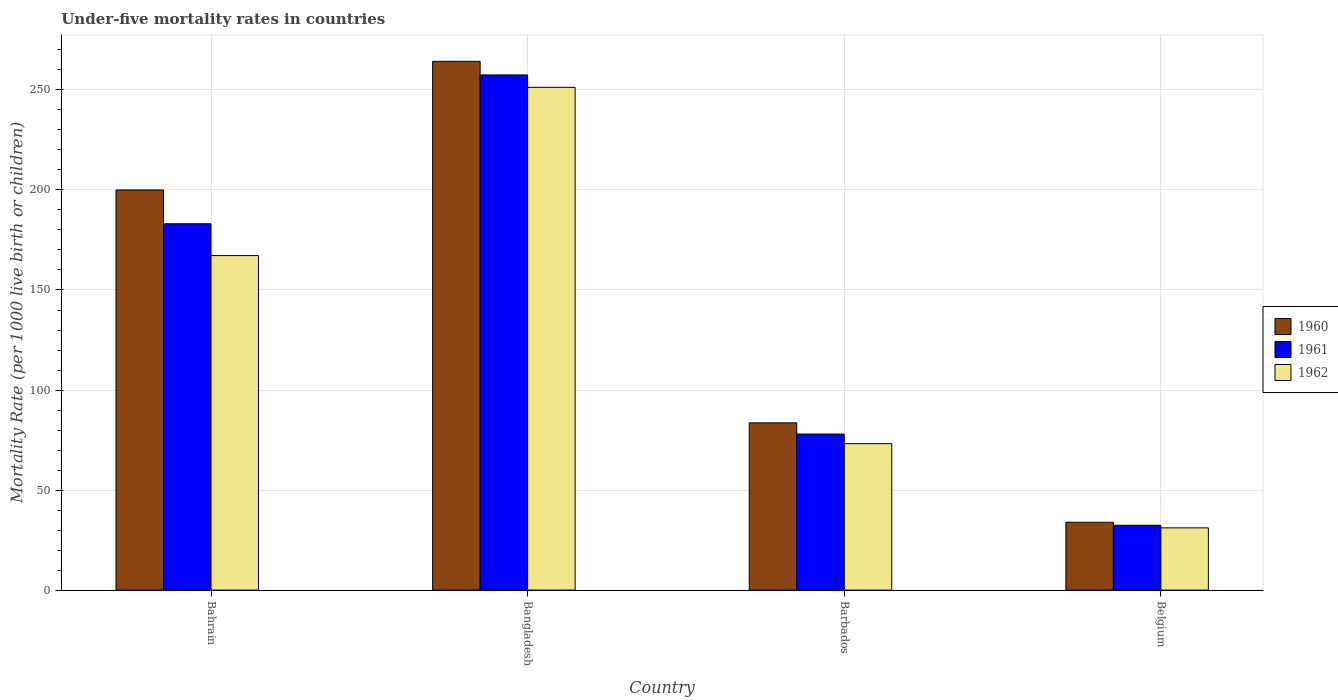How many different coloured bars are there?
Your answer should be compact. 3. Are the number of bars on each tick of the X-axis equal?
Offer a very short reply. Yes. How many bars are there on the 1st tick from the left?
Give a very brief answer. 3. How many bars are there on the 2nd tick from the right?
Provide a short and direct response. 3. What is the under-five mortality rate in 1962 in Belgium?
Provide a short and direct response. 31.1. Across all countries, what is the maximum under-five mortality rate in 1961?
Keep it short and to the point. 257.5. Across all countries, what is the minimum under-five mortality rate in 1960?
Provide a succinct answer. 33.9. What is the total under-five mortality rate in 1961 in the graph?
Provide a short and direct response. 551. What is the difference between the under-five mortality rate in 1960 in Bahrain and that in Bangladesh?
Make the answer very short. -64.3. What is the difference between the under-five mortality rate in 1960 in Bangladesh and the under-five mortality rate in 1962 in Barbados?
Your response must be concise. 191.1. What is the average under-five mortality rate in 1961 per country?
Your response must be concise. 137.75. What is the difference between the under-five mortality rate of/in 1961 and under-five mortality rate of/in 1960 in Bahrain?
Provide a short and direct response. -16.9. What is the ratio of the under-five mortality rate in 1960 in Barbados to that in Belgium?
Your response must be concise. 2.47. What is the difference between the highest and the second highest under-five mortality rate in 1960?
Offer a terse response. 180.7. What is the difference between the highest and the lowest under-five mortality rate in 1960?
Ensure brevity in your answer.  230.4. In how many countries, is the under-five mortality rate in 1960 greater than the average under-five mortality rate in 1960 taken over all countries?
Offer a very short reply. 2. What does the 3rd bar from the right in Belgium represents?
Make the answer very short. 1960. Is it the case that in every country, the sum of the under-five mortality rate in 1960 and under-five mortality rate in 1961 is greater than the under-five mortality rate in 1962?
Provide a short and direct response. Yes. Are all the bars in the graph horizontal?
Provide a succinct answer. No. Does the graph contain grids?
Offer a very short reply. Yes. What is the title of the graph?
Your response must be concise. Under-five mortality rates in countries. What is the label or title of the Y-axis?
Your response must be concise. Mortality Rate (per 1000 live birth or children). What is the Mortality Rate (per 1000 live birth or children) of 1961 in Bahrain?
Offer a terse response. 183.1. What is the Mortality Rate (per 1000 live birth or children) in 1962 in Bahrain?
Make the answer very short. 167.2. What is the Mortality Rate (per 1000 live birth or children) of 1960 in Bangladesh?
Offer a very short reply. 264.3. What is the Mortality Rate (per 1000 live birth or children) of 1961 in Bangladesh?
Your answer should be very brief. 257.5. What is the Mortality Rate (per 1000 live birth or children) of 1962 in Bangladesh?
Your answer should be compact. 251.3. What is the Mortality Rate (per 1000 live birth or children) of 1960 in Barbados?
Provide a succinct answer. 83.6. What is the Mortality Rate (per 1000 live birth or children) in 1962 in Barbados?
Your response must be concise. 73.2. What is the Mortality Rate (per 1000 live birth or children) in 1960 in Belgium?
Offer a very short reply. 33.9. What is the Mortality Rate (per 1000 live birth or children) in 1961 in Belgium?
Ensure brevity in your answer.  32.4. What is the Mortality Rate (per 1000 live birth or children) in 1962 in Belgium?
Offer a very short reply. 31.1. Across all countries, what is the maximum Mortality Rate (per 1000 live birth or children) of 1960?
Offer a terse response. 264.3. Across all countries, what is the maximum Mortality Rate (per 1000 live birth or children) of 1961?
Make the answer very short. 257.5. Across all countries, what is the maximum Mortality Rate (per 1000 live birth or children) of 1962?
Your answer should be compact. 251.3. Across all countries, what is the minimum Mortality Rate (per 1000 live birth or children) in 1960?
Your answer should be compact. 33.9. Across all countries, what is the minimum Mortality Rate (per 1000 live birth or children) of 1961?
Ensure brevity in your answer.  32.4. Across all countries, what is the minimum Mortality Rate (per 1000 live birth or children) of 1962?
Your response must be concise. 31.1. What is the total Mortality Rate (per 1000 live birth or children) in 1960 in the graph?
Keep it short and to the point. 581.8. What is the total Mortality Rate (per 1000 live birth or children) of 1961 in the graph?
Keep it short and to the point. 551. What is the total Mortality Rate (per 1000 live birth or children) of 1962 in the graph?
Your answer should be very brief. 522.8. What is the difference between the Mortality Rate (per 1000 live birth or children) in 1960 in Bahrain and that in Bangladesh?
Offer a very short reply. -64.3. What is the difference between the Mortality Rate (per 1000 live birth or children) in 1961 in Bahrain and that in Bangladesh?
Provide a succinct answer. -74.4. What is the difference between the Mortality Rate (per 1000 live birth or children) of 1962 in Bahrain and that in Bangladesh?
Make the answer very short. -84.1. What is the difference between the Mortality Rate (per 1000 live birth or children) of 1960 in Bahrain and that in Barbados?
Offer a very short reply. 116.4. What is the difference between the Mortality Rate (per 1000 live birth or children) of 1961 in Bahrain and that in Barbados?
Your answer should be compact. 105.1. What is the difference between the Mortality Rate (per 1000 live birth or children) in 1962 in Bahrain and that in Barbados?
Provide a short and direct response. 94. What is the difference between the Mortality Rate (per 1000 live birth or children) in 1960 in Bahrain and that in Belgium?
Give a very brief answer. 166.1. What is the difference between the Mortality Rate (per 1000 live birth or children) in 1961 in Bahrain and that in Belgium?
Offer a terse response. 150.7. What is the difference between the Mortality Rate (per 1000 live birth or children) of 1962 in Bahrain and that in Belgium?
Provide a short and direct response. 136.1. What is the difference between the Mortality Rate (per 1000 live birth or children) of 1960 in Bangladesh and that in Barbados?
Your response must be concise. 180.7. What is the difference between the Mortality Rate (per 1000 live birth or children) in 1961 in Bangladesh and that in Barbados?
Your response must be concise. 179.5. What is the difference between the Mortality Rate (per 1000 live birth or children) of 1962 in Bangladesh and that in Barbados?
Your answer should be compact. 178.1. What is the difference between the Mortality Rate (per 1000 live birth or children) in 1960 in Bangladesh and that in Belgium?
Give a very brief answer. 230.4. What is the difference between the Mortality Rate (per 1000 live birth or children) in 1961 in Bangladesh and that in Belgium?
Your response must be concise. 225.1. What is the difference between the Mortality Rate (per 1000 live birth or children) of 1962 in Bangladesh and that in Belgium?
Ensure brevity in your answer.  220.2. What is the difference between the Mortality Rate (per 1000 live birth or children) of 1960 in Barbados and that in Belgium?
Your response must be concise. 49.7. What is the difference between the Mortality Rate (per 1000 live birth or children) of 1961 in Barbados and that in Belgium?
Your answer should be very brief. 45.6. What is the difference between the Mortality Rate (per 1000 live birth or children) of 1962 in Barbados and that in Belgium?
Your answer should be very brief. 42.1. What is the difference between the Mortality Rate (per 1000 live birth or children) in 1960 in Bahrain and the Mortality Rate (per 1000 live birth or children) in 1961 in Bangladesh?
Keep it short and to the point. -57.5. What is the difference between the Mortality Rate (per 1000 live birth or children) in 1960 in Bahrain and the Mortality Rate (per 1000 live birth or children) in 1962 in Bangladesh?
Provide a succinct answer. -51.3. What is the difference between the Mortality Rate (per 1000 live birth or children) in 1961 in Bahrain and the Mortality Rate (per 1000 live birth or children) in 1962 in Bangladesh?
Keep it short and to the point. -68.2. What is the difference between the Mortality Rate (per 1000 live birth or children) of 1960 in Bahrain and the Mortality Rate (per 1000 live birth or children) of 1961 in Barbados?
Offer a terse response. 122. What is the difference between the Mortality Rate (per 1000 live birth or children) in 1960 in Bahrain and the Mortality Rate (per 1000 live birth or children) in 1962 in Barbados?
Offer a very short reply. 126.8. What is the difference between the Mortality Rate (per 1000 live birth or children) in 1961 in Bahrain and the Mortality Rate (per 1000 live birth or children) in 1962 in Barbados?
Keep it short and to the point. 109.9. What is the difference between the Mortality Rate (per 1000 live birth or children) in 1960 in Bahrain and the Mortality Rate (per 1000 live birth or children) in 1961 in Belgium?
Make the answer very short. 167.6. What is the difference between the Mortality Rate (per 1000 live birth or children) of 1960 in Bahrain and the Mortality Rate (per 1000 live birth or children) of 1962 in Belgium?
Your response must be concise. 168.9. What is the difference between the Mortality Rate (per 1000 live birth or children) in 1961 in Bahrain and the Mortality Rate (per 1000 live birth or children) in 1962 in Belgium?
Ensure brevity in your answer.  152. What is the difference between the Mortality Rate (per 1000 live birth or children) of 1960 in Bangladesh and the Mortality Rate (per 1000 live birth or children) of 1961 in Barbados?
Provide a short and direct response. 186.3. What is the difference between the Mortality Rate (per 1000 live birth or children) in 1960 in Bangladesh and the Mortality Rate (per 1000 live birth or children) in 1962 in Barbados?
Your answer should be compact. 191.1. What is the difference between the Mortality Rate (per 1000 live birth or children) in 1961 in Bangladesh and the Mortality Rate (per 1000 live birth or children) in 1962 in Barbados?
Offer a very short reply. 184.3. What is the difference between the Mortality Rate (per 1000 live birth or children) of 1960 in Bangladesh and the Mortality Rate (per 1000 live birth or children) of 1961 in Belgium?
Give a very brief answer. 231.9. What is the difference between the Mortality Rate (per 1000 live birth or children) in 1960 in Bangladesh and the Mortality Rate (per 1000 live birth or children) in 1962 in Belgium?
Offer a terse response. 233.2. What is the difference between the Mortality Rate (per 1000 live birth or children) of 1961 in Bangladesh and the Mortality Rate (per 1000 live birth or children) of 1962 in Belgium?
Your answer should be compact. 226.4. What is the difference between the Mortality Rate (per 1000 live birth or children) in 1960 in Barbados and the Mortality Rate (per 1000 live birth or children) in 1961 in Belgium?
Offer a terse response. 51.2. What is the difference between the Mortality Rate (per 1000 live birth or children) in 1960 in Barbados and the Mortality Rate (per 1000 live birth or children) in 1962 in Belgium?
Your answer should be compact. 52.5. What is the difference between the Mortality Rate (per 1000 live birth or children) in 1961 in Barbados and the Mortality Rate (per 1000 live birth or children) in 1962 in Belgium?
Give a very brief answer. 46.9. What is the average Mortality Rate (per 1000 live birth or children) in 1960 per country?
Your response must be concise. 145.45. What is the average Mortality Rate (per 1000 live birth or children) of 1961 per country?
Your response must be concise. 137.75. What is the average Mortality Rate (per 1000 live birth or children) of 1962 per country?
Provide a succinct answer. 130.7. What is the difference between the Mortality Rate (per 1000 live birth or children) of 1960 and Mortality Rate (per 1000 live birth or children) of 1961 in Bahrain?
Your answer should be compact. 16.9. What is the difference between the Mortality Rate (per 1000 live birth or children) in 1960 and Mortality Rate (per 1000 live birth or children) in 1962 in Bahrain?
Give a very brief answer. 32.8. What is the difference between the Mortality Rate (per 1000 live birth or children) of 1961 and Mortality Rate (per 1000 live birth or children) of 1962 in Bangladesh?
Offer a very short reply. 6.2. What is the difference between the Mortality Rate (per 1000 live birth or children) of 1960 and Mortality Rate (per 1000 live birth or children) of 1962 in Barbados?
Your answer should be compact. 10.4. What is the difference between the Mortality Rate (per 1000 live birth or children) of 1961 and Mortality Rate (per 1000 live birth or children) of 1962 in Barbados?
Your answer should be compact. 4.8. What is the difference between the Mortality Rate (per 1000 live birth or children) of 1960 and Mortality Rate (per 1000 live birth or children) of 1962 in Belgium?
Your answer should be very brief. 2.8. What is the difference between the Mortality Rate (per 1000 live birth or children) of 1961 and Mortality Rate (per 1000 live birth or children) of 1962 in Belgium?
Give a very brief answer. 1.3. What is the ratio of the Mortality Rate (per 1000 live birth or children) of 1960 in Bahrain to that in Bangladesh?
Keep it short and to the point. 0.76. What is the ratio of the Mortality Rate (per 1000 live birth or children) of 1961 in Bahrain to that in Bangladesh?
Keep it short and to the point. 0.71. What is the ratio of the Mortality Rate (per 1000 live birth or children) of 1962 in Bahrain to that in Bangladesh?
Provide a succinct answer. 0.67. What is the ratio of the Mortality Rate (per 1000 live birth or children) of 1960 in Bahrain to that in Barbados?
Provide a succinct answer. 2.39. What is the ratio of the Mortality Rate (per 1000 live birth or children) of 1961 in Bahrain to that in Barbados?
Offer a terse response. 2.35. What is the ratio of the Mortality Rate (per 1000 live birth or children) of 1962 in Bahrain to that in Barbados?
Keep it short and to the point. 2.28. What is the ratio of the Mortality Rate (per 1000 live birth or children) of 1960 in Bahrain to that in Belgium?
Your answer should be very brief. 5.9. What is the ratio of the Mortality Rate (per 1000 live birth or children) in 1961 in Bahrain to that in Belgium?
Offer a very short reply. 5.65. What is the ratio of the Mortality Rate (per 1000 live birth or children) of 1962 in Bahrain to that in Belgium?
Give a very brief answer. 5.38. What is the ratio of the Mortality Rate (per 1000 live birth or children) of 1960 in Bangladesh to that in Barbados?
Keep it short and to the point. 3.16. What is the ratio of the Mortality Rate (per 1000 live birth or children) in 1961 in Bangladesh to that in Barbados?
Ensure brevity in your answer.  3.3. What is the ratio of the Mortality Rate (per 1000 live birth or children) in 1962 in Bangladesh to that in Barbados?
Your answer should be compact. 3.43. What is the ratio of the Mortality Rate (per 1000 live birth or children) in 1960 in Bangladesh to that in Belgium?
Offer a very short reply. 7.8. What is the ratio of the Mortality Rate (per 1000 live birth or children) of 1961 in Bangladesh to that in Belgium?
Provide a short and direct response. 7.95. What is the ratio of the Mortality Rate (per 1000 live birth or children) in 1962 in Bangladesh to that in Belgium?
Give a very brief answer. 8.08. What is the ratio of the Mortality Rate (per 1000 live birth or children) of 1960 in Barbados to that in Belgium?
Your response must be concise. 2.47. What is the ratio of the Mortality Rate (per 1000 live birth or children) of 1961 in Barbados to that in Belgium?
Your answer should be very brief. 2.41. What is the ratio of the Mortality Rate (per 1000 live birth or children) in 1962 in Barbados to that in Belgium?
Keep it short and to the point. 2.35. What is the difference between the highest and the second highest Mortality Rate (per 1000 live birth or children) in 1960?
Provide a succinct answer. 64.3. What is the difference between the highest and the second highest Mortality Rate (per 1000 live birth or children) of 1961?
Provide a succinct answer. 74.4. What is the difference between the highest and the second highest Mortality Rate (per 1000 live birth or children) in 1962?
Provide a short and direct response. 84.1. What is the difference between the highest and the lowest Mortality Rate (per 1000 live birth or children) in 1960?
Ensure brevity in your answer.  230.4. What is the difference between the highest and the lowest Mortality Rate (per 1000 live birth or children) of 1961?
Your response must be concise. 225.1. What is the difference between the highest and the lowest Mortality Rate (per 1000 live birth or children) in 1962?
Offer a very short reply. 220.2. 